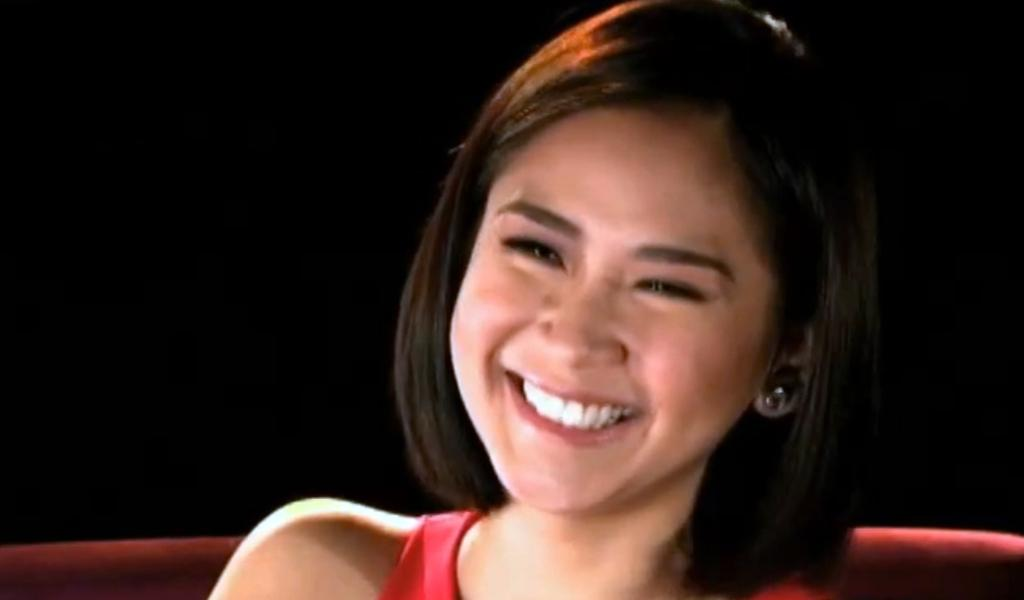What is the main subject of the image? The main subject of the image is a woman. What is the woman doing in the image? The woman is sitting in the image. What is the woman's facial expression in the image? The woman is smiling in the image. What type of gun is the woman holding in the image? There is no gun present in the image; the woman is simply sitting and smiling. 